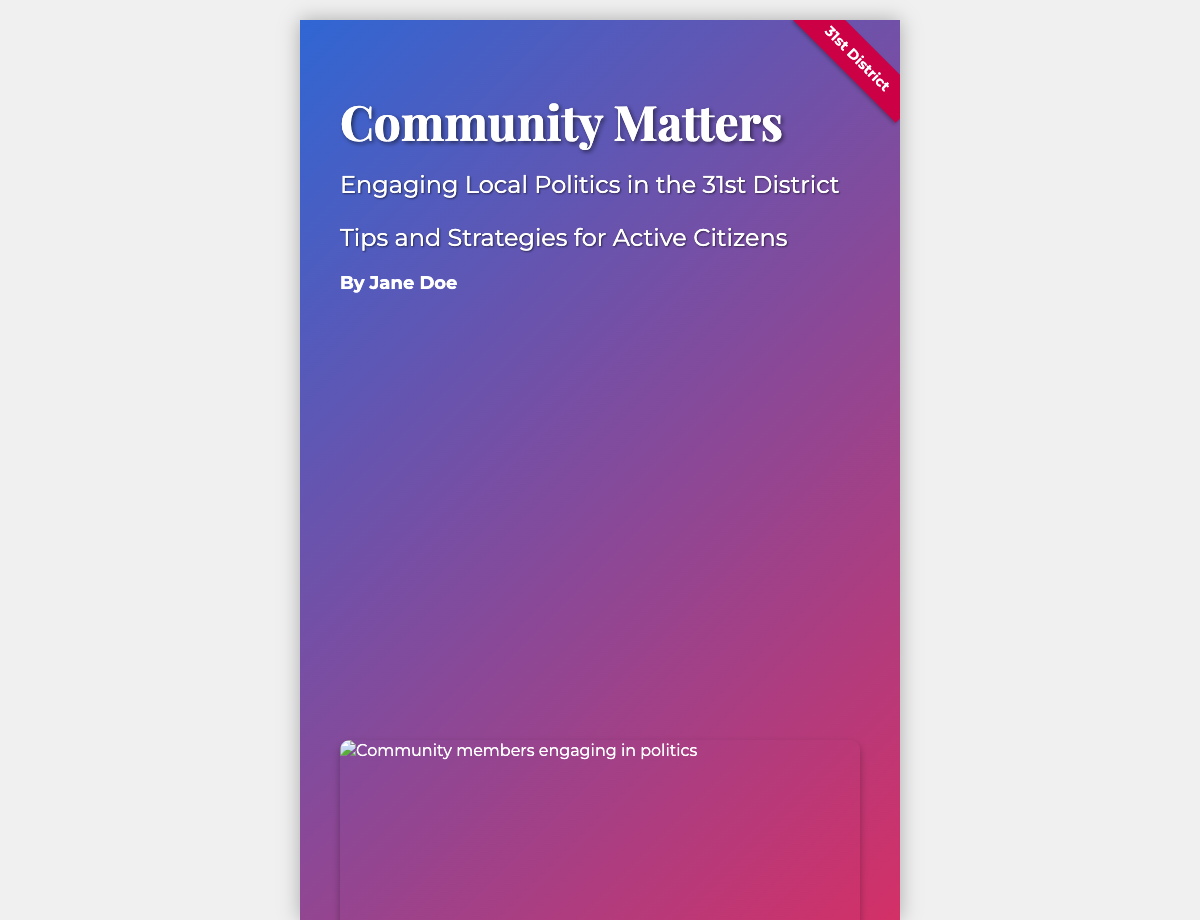What is the title of the book? The title of the book is prominently displayed at the top of the cover.
Answer: Community Matters Who is the author of the book? The author's name is mentioned below the book title.
Answer: Jane Doe What is the subtitle of the book? The subtitle appears immediately under the title and provides additional context.
Answer: Engaging Local Politics in the 31st District What is included in the foreword? The foreword section at the bottom of the cover credits an important political figure with a brief mention.
Answer: Congresswoman Victoria Spartz What type of image is featured on the cover? The image is situated below the author's name and represents community engagement.
Answer: Community members engaging in politics What district does the book focus on? The ribbon graphic on the side highlights which district the book addresses.
Answer: 31st District How many subtitles are listed on the cover? There are multiple subtitles that illustrate the focus of the book shown below the main title.
Answer: Two subtitles What style of font is used for the title? The font style is indicated in the CSS section and represents the importance of the title typography.
Answer: Playfair Display What color scheme is used for the overlay on the cover? The colors of the overlay are specified in the design description to enhance visual appeal.
Answer: Blue and Red 